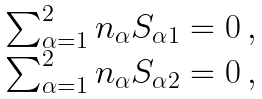<formula> <loc_0><loc_0><loc_500><loc_500>\begin{array} { l } \sum _ { \alpha = 1 } ^ { 2 } n _ { \alpha } S _ { \alpha 1 } = 0 \, , \\ \sum _ { \alpha = 1 } ^ { 2 } n _ { \alpha } S _ { \alpha 2 } = 0 \, , \end{array}</formula> 